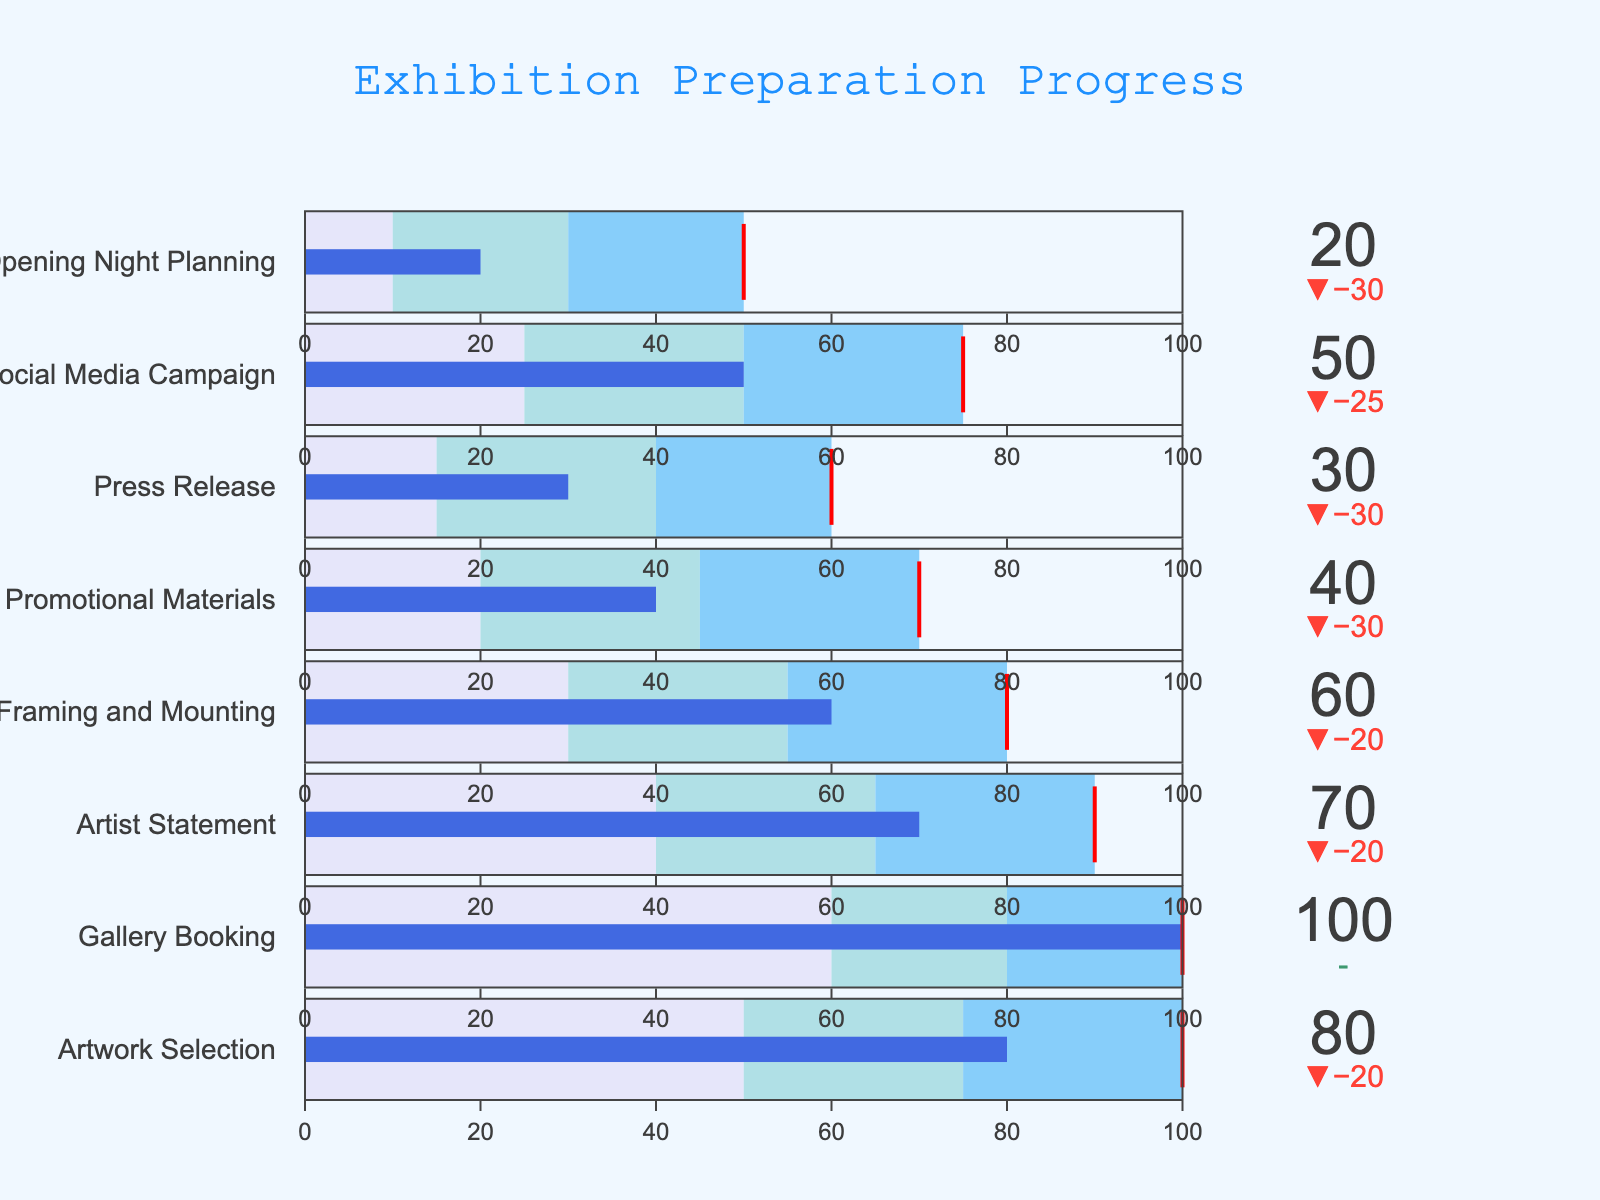What is the target value for the 'Artist Statement' task? The target value for the 'Artist Statement' task can be directly observed from the figure.
Answer: 90 What is the actual progress of the 'Social Media Campaign' compared to its target? To answer this, look at the 'Social Media Campaign' bullet. The actual progress is represented by the bar, and the delta value shows the difference from the target. The actual progress is 50, and the target is 75.
Answer: 50 out of 75 How does the 'Gallery Booking' task compare to the 'Artwork Selection' task in terms of actual progress? Compare the actual progress bars for 'Gallery Booking' and 'Artwork Selection'. 'Gallery Booking' has an actual progress of 100, whereas 'Artwork Selection' has 80.
Answer: 'Gallery Booking' is 20 points higher than 'Artwork Selection' Which task has the lowest actual progress? Scan through the actual progress values for all tasks.
Answer: 'Opening Night Planning' with 20 How many tasks have met or exceeded their target values? By examining each bullet chart, check if the actual progress bar reaches or surpasses the target mark. 'Gallery Booking' and 'Artwork Selection' have met or exceeded their targets.
Answer: 2 tasks What is the average target value for all tasks? Sum all the target values and divide by the number of tasks (100 + 100 + 90 + 80 + 70 + 60 + 75 + 50) / 8.
Answer: 78.1 Which tasks have their actual progress within the second range (light blue)? Check the tasks where actual progress falls within the range middle color, light blue.
Answer: 'Artist Statement' and 'Framing and Mounting' How far is the 'Promotional Materials' task from its target? Subtract the actual progress of the 'Promotional Materials' task from its target (70 - 40).
Answer: 30 units What is the total actual progress for all tasks combined? Sum all the actual progress values (80 + 100 + 70 + 60 + 40 + 30 + 50 + 20).
Answer: 450 Which task is behind the most in terms of progress compared to its target? Calculate the difference between actual and target values for each task. The task with the largest negative difference is the one most behind. 'Press Release' has a difference of -30 since its actual progress is 30, and the target is 60.
Answer: 'Press Release' 